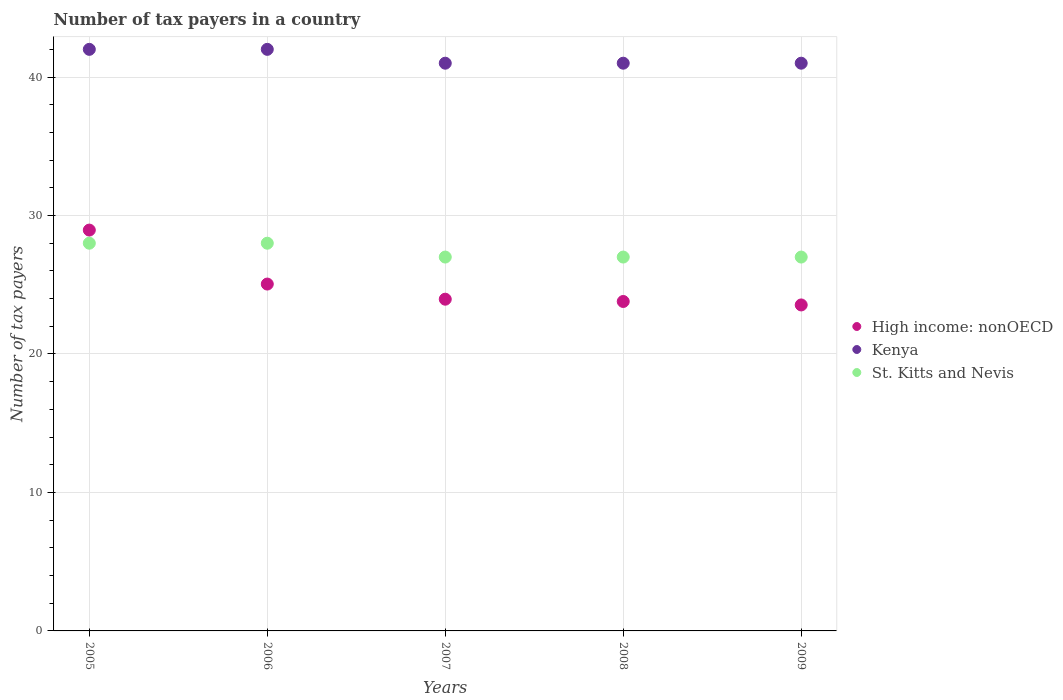How many different coloured dotlines are there?
Your answer should be compact. 3. What is the number of tax payers in in Kenya in 2008?
Make the answer very short. 41. Across all years, what is the maximum number of tax payers in in High income: nonOECD?
Your answer should be compact. 28.95. Across all years, what is the minimum number of tax payers in in Kenya?
Your answer should be very brief. 41. In which year was the number of tax payers in in Kenya maximum?
Your answer should be compact. 2005. In which year was the number of tax payers in in St. Kitts and Nevis minimum?
Offer a very short reply. 2007. What is the total number of tax payers in in High income: nonOECD in the graph?
Your answer should be compact. 125.29. What is the difference between the number of tax payers in in High income: nonOECD in 2007 and that in 2009?
Provide a succinct answer. 0.41. What is the difference between the number of tax payers in in St. Kitts and Nevis in 2006 and the number of tax payers in in Kenya in 2008?
Your answer should be compact. -13. What is the average number of tax payers in in High income: nonOECD per year?
Provide a succinct answer. 25.06. In the year 2005, what is the difference between the number of tax payers in in High income: nonOECD and number of tax payers in in St. Kitts and Nevis?
Offer a terse response. 0.95. What is the ratio of the number of tax payers in in High income: nonOECD in 2006 to that in 2007?
Provide a short and direct response. 1.05. Is the number of tax payers in in High income: nonOECD in 2008 less than that in 2009?
Give a very brief answer. No. Is the difference between the number of tax payers in in High income: nonOECD in 2007 and 2009 greater than the difference between the number of tax payers in in St. Kitts and Nevis in 2007 and 2009?
Your answer should be compact. Yes. What is the difference between the highest and the second highest number of tax payers in in St. Kitts and Nevis?
Provide a succinct answer. 0. What is the difference between the highest and the lowest number of tax payers in in Kenya?
Ensure brevity in your answer.  1. In how many years, is the number of tax payers in in Kenya greater than the average number of tax payers in in Kenya taken over all years?
Your answer should be very brief. 2. Is the sum of the number of tax payers in in Kenya in 2008 and 2009 greater than the maximum number of tax payers in in St. Kitts and Nevis across all years?
Offer a terse response. Yes. Is it the case that in every year, the sum of the number of tax payers in in St. Kitts and Nevis and number of tax payers in in High income: nonOECD  is greater than the number of tax payers in in Kenya?
Your answer should be very brief. Yes. Does the number of tax payers in in St. Kitts and Nevis monotonically increase over the years?
Your answer should be compact. No. Is the number of tax payers in in High income: nonOECD strictly less than the number of tax payers in in St. Kitts and Nevis over the years?
Your response must be concise. No. How many years are there in the graph?
Provide a succinct answer. 5. What is the difference between two consecutive major ticks on the Y-axis?
Give a very brief answer. 10. Are the values on the major ticks of Y-axis written in scientific E-notation?
Your answer should be compact. No. Does the graph contain any zero values?
Offer a very short reply. No. How many legend labels are there?
Offer a very short reply. 3. How are the legend labels stacked?
Offer a very short reply. Vertical. What is the title of the graph?
Your response must be concise. Number of tax payers in a country. What is the label or title of the Y-axis?
Provide a short and direct response. Number of tax payers. What is the Number of tax payers in High income: nonOECD in 2005?
Your answer should be very brief. 28.95. What is the Number of tax payers in St. Kitts and Nevis in 2005?
Your answer should be very brief. 28. What is the Number of tax payers in High income: nonOECD in 2006?
Your answer should be very brief. 25.05. What is the Number of tax payers of Kenya in 2006?
Ensure brevity in your answer.  42. What is the Number of tax payers in St. Kitts and Nevis in 2006?
Your answer should be very brief. 28. What is the Number of tax payers in High income: nonOECD in 2007?
Provide a short and direct response. 23.96. What is the Number of tax payers in Kenya in 2007?
Your answer should be compact. 41. What is the Number of tax payers of St. Kitts and Nevis in 2007?
Offer a very short reply. 27. What is the Number of tax payers in High income: nonOECD in 2008?
Offer a terse response. 23.79. What is the Number of tax payers of High income: nonOECD in 2009?
Your answer should be compact. 23.54. Across all years, what is the maximum Number of tax payers in High income: nonOECD?
Offer a very short reply. 28.95. Across all years, what is the minimum Number of tax payers in High income: nonOECD?
Provide a short and direct response. 23.54. Across all years, what is the minimum Number of tax payers of St. Kitts and Nevis?
Your answer should be compact. 27. What is the total Number of tax payers in High income: nonOECD in the graph?
Offer a very short reply. 125.29. What is the total Number of tax payers of Kenya in the graph?
Make the answer very short. 207. What is the total Number of tax payers of St. Kitts and Nevis in the graph?
Offer a very short reply. 137. What is the difference between the Number of tax payers of High income: nonOECD in 2005 and that in 2006?
Your response must be concise. 3.9. What is the difference between the Number of tax payers of St. Kitts and Nevis in 2005 and that in 2006?
Your answer should be very brief. 0. What is the difference between the Number of tax payers of High income: nonOECD in 2005 and that in 2007?
Provide a succinct answer. 4.99. What is the difference between the Number of tax payers of Kenya in 2005 and that in 2007?
Offer a terse response. 1. What is the difference between the Number of tax payers of High income: nonOECD in 2005 and that in 2008?
Give a very brief answer. 5.16. What is the difference between the Number of tax payers of Kenya in 2005 and that in 2008?
Make the answer very short. 1. What is the difference between the Number of tax payers in St. Kitts and Nevis in 2005 and that in 2008?
Ensure brevity in your answer.  1. What is the difference between the Number of tax payers in High income: nonOECD in 2005 and that in 2009?
Your response must be concise. 5.41. What is the difference between the Number of tax payers in Kenya in 2005 and that in 2009?
Provide a short and direct response. 1. What is the difference between the Number of tax payers of St. Kitts and Nevis in 2005 and that in 2009?
Provide a succinct answer. 1. What is the difference between the Number of tax payers of High income: nonOECD in 2006 and that in 2007?
Ensure brevity in your answer.  1.09. What is the difference between the Number of tax payers of High income: nonOECD in 2006 and that in 2008?
Offer a very short reply. 1.26. What is the difference between the Number of tax payers of Kenya in 2006 and that in 2008?
Your response must be concise. 1. What is the difference between the Number of tax payers of St. Kitts and Nevis in 2006 and that in 2008?
Your answer should be compact. 1. What is the difference between the Number of tax payers in High income: nonOECD in 2006 and that in 2009?
Ensure brevity in your answer.  1.51. What is the difference between the Number of tax payers of Kenya in 2006 and that in 2009?
Your answer should be compact. 1. What is the difference between the Number of tax payers in High income: nonOECD in 2007 and that in 2008?
Provide a short and direct response. 0.16. What is the difference between the Number of tax payers of St. Kitts and Nevis in 2007 and that in 2008?
Your answer should be very brief. 0. What is the difference between the Number of tax payers of High income: nonOECD in 2007 and that in 2009?
Give a very brief answer. 0.41. What is the difference between the Number of tax payers of High income: nonOECD in 2008 and that in 2009?
Offer a very short reply. 0.25. What is the difference between the Number of tax payers of St. Kitts and Nevis in 2008 and that in 2009?
Your response must be concise. 0. What is the difference between the Number of tax payers in High income: nonOECD in 2005 and the Number of tax payers in Kenya in 2006?
Keep it short and to the point. -13.05. What is the difference between the Number of tax payers in Kenya in 2005 and the Number of tax payers in St. Kitts and Nevis in 2006?
Keep it short and to the point. 14. What is the difference between the Number of tax payers of High income: nonOECD in 2005 and the Number of tax payers of Kenya in 2007?
Make the answer very short. -12.05. What is the difference between the Number of tax payers of High income: nonOECD in 2005 and the Number of tax payers of St. Kitts and Nevis in 2007?
Keep it short and to the point. 1.95. What is the difference between the Number of tax payers of High income: nonOECD in 2005 and the Number of tax payers of Kenya in 2008?
Ensure brevity in your answer.  -12.05. What is the difference between the Number of tax payers in High income: nonOECD in 2005 and the Number of tax payers in St. Kitts and Nevis in 2008?
Keep it short and to the point. 1.95. What is the difference between the Number of tax payers in High income: nonOECD in 2005 and the Number of tax payers in Kenya in 2009?
Make the answer very short. -12.05. What is the difference between the Number of tax payers of High income: nonOECD in 2005 and the Number of tax payers of St. Kitts and Nevis in 2009?
Make the answer very short. 1.95. What is the difference between the Number of tax payers in Kenya in 2005 and the Number of tax payers in St. Kitts and Nevis in 2009?
Your answer should be compact. 15. What is the difference between the Number of tax payers of High income: nonOECD in 2006 and the Number of tax payers of Kenya in 2007?
Your answer should be compact. -15.95. What is the difference between the Number of tax payers in High income: nonOECD in 2006 and the Number of tax payers in St. Kitts and Nevis in 2007?
Provide a succinct answer. -1.95. What is the difference between the Number of tax payers of Kenya in 2006 and the Number of tax payers of St. Kitts and Nevis in 2007?
Give a very brief answer. 15. What is the difference between the Number of tax payers of High income: nonOECD in 2006 and the Number of tax payers of Kenya in 2008?
Offer a terse response. -15.95. What is the difference between the Number of tax payers of High income: nonOECD in 2006 and the Number of tax payers of St. Kitts and Nevis in 2008?
Ensure brevity in your answer.  -1.95. What is the difference between the Number of tax payers of High income: nonOECD in 2006 and the Number of tax payers of Kenya in 2009?
Provide a succinct answer. -15.95. What is the difference between the Number of tax payers in High income: nonOECD in 2006 and the Number of tax payers in St. Kitts and Nevis in 2009?
Give a very brief answer. -1.95. What is the difference between the Number of tax payers of Kenya in 2006 and the Number of tax payers of St. Kitts and Nevis in 2009?
Your response must be concise. 15. What is the difference between the Number of tax payers of High income: nonOECD in 2007 and the Number of tax payers of Kenya in 2008?
Your answer should be compact. -17.04. What is the difference between the Number of tax payers of High income: nonOECD in 2007 and the Number of tax payers of St. Kitts and Nevis in 2008?
Make the answer very short. -3.04. What is the difference between the Number of tax payers of High income: nonOECD in 2007 and the Number of tax payers of Kenya in 2009?
Your answer should be very brief. -17.04. What is the difference between the Number of tax payers of High income: nonOECD in 2007 and the Number of tax payers of St. Kitts and Nevis in 2009?
Provide a short and direct response. -3.04. What is the difference between the Number of tax payers in Kenya in 2007 and the Number of tax payers in St. Kitts and Nevis in 2009?
Offer a very short reply. 14. What is the difference between the Number of tax payers of High income: nonOECD in 2008 and the Number of tax payers of Kenya in 2009?
Your answer should be very brief. -17.21. What is the difference between the Number of tax payers of High income: nonOECD in 2008 and the Number of tax payers of St. Kitts and Nevis in 2009?
Provide a short and direct response. -3.21. What is the difference between the Number of tax payers in Kenya in 2008 and the Number of tax payers in St. Kitts and Nevis in 2009?
Offer a very short reply. 14. What is the average Number of tax payers in High income: nonOECD per year?
Give a very brief answer. 25.06. What is the average Number of tax payers of Kenya per year?
Your answer should be compact. 41.4. What is the average Number of tax payers in St. Kitts and Nevis per year?
Your answer should be compact. 27.4. In the year 2005, what is the difference between the Number of tax payers of High income: nonOECD and Number of tax payers of Kenya?
Your answer should be very brief. -13.05. In the year 2006, what is the difference between the Number of tax payers of High income: nonOECD and Number of tax payers of Kenya?
Provide a short and direct response. -16.95. In the year 2006, what is the difference between the Number of tax payers of High income: nonOECD and Number of tax payers of St. Kitts and Nevis?
Provide a succinct answer. -2.95. In the year 2006, what is the difference between the Number of tax payers in Kenya and Number of tax payers in St. Kitts and Nevis?
Keep it short and to the point. 14. In the year 2007, what is the difference between the Number of tax payers of High income: nonOECD and Number of tax payers of Kenya?
Your answer should be compact. -17.04. In the year 2007, what is the difference between the Number of tax payers in High income: nonOECD and Number of tax payers in St. Kitts and Nevis?
Give a very brief answer. -3.04. In the year 2007, what is the difference between the Number of tax payers in Kenya and Number of tax payers in St. Kitts and Nevis?
Keep it short and to the point. 14. In the year 2008, what is the difference between the Number of tax payers in High income: nonOECD and Number of tax payers in Kenya?
Your answer should be very brief. -17.21. In the year 2008, what is the difference between the Number of tax payers of High income: nonOECD and Number of tax payers of St. Kitts and Nevis?
Provide a succinct answer. -3.21. In the year 2008, what is the difference between the Number of tax payers in Kenya and Number of tax payers in St. Kitts and Nevis?
Offer a very short reply. 14. In the year 2009, what is the difference between the Number of tax payers in High income: nonOECD and Number of tax payers in Kenya?
Give a very brief answer. -17.46. In the year 2009, what is the difference between the Number of tax payers in High income: nonOECD and Number of tax payers in St. Kitts and Nevis?
Make the answer very short. -3.46. What is the ratio of the Number of tax payers in High income: nonOECD in 2005 to that in 2006?
Keep it short and to the point. 1.16. What is the ratio of the Number of tax payers in Kenya in 2005 to that in 2006?
Provide a succinct answer. 1. What is the ratio of the Number of tax payers in High income: nonOECD in 2005 to that in 2007?
Keep it short and to the point. 1.21. What is the ratio of the Number of tax payers of Kenya in 2005 to that in 2007?
Provide a succinct answer. 1.02. What is the ratio of the Number of tax payers of St. Kitts and Nevis in 2005 to that in 2007?
Ensure brevity in your answer.  1.04. What is the ratio of the Number of tax payers in High income: nonOECD in 2005 to that in 2008?
Offer a very short reply. 1.22. What is the ratio of the Number of tax payers in Kenya in 2005 to that in 2008?
Offer a very short reply. 1.02. What is the ratio of the Number of tax payers in High income: nonOECD in 2005 to that in 2009?
Make the answer very short. 1.23. What is the ratio of the Number of tax payers of Kenya in 2005 to that in 2009?
Give a very brief answer. 1.02. What is the ratio of the Number of tax payers of High income: nonOECD in 2006 to that in 2007?
Your answer should be compact. 1.05. What is the ratio of the Number of tax payers in Kenya in 2006 to that in 2007?
Offer a very short reply. 1.02. What is the ratio of the Number of tax payers of St. Kitts and Nevis in 2006 to that in 2007?
Provide a succinct answer. 1.04. What is the ratio of the Number of tax payers of High income: nonOECD in 2006 to that in 2008?
Your response must be concise. 1.05. What is the ratio of the Number of tax payers of Kenya in 2006 to that in 2008?
Give a very brief answer. 1.02. What is the ratio of the Number of tax payers in High income: nonOECD in 2006 to that in 2009?
Your answer should be compact. 1.06. What is the ratio of the Number of tax payers of Kenya in 2006 to that in 2009?
Your answer should be compact. 1.02. What is the ratio of the Number of tax payers in St. Kitts and Nevis in 2006 to that in 2009?
Provide a succinct answer. 1.04. What is the ratio of the Number of tax payers in High income: nonOECD in 2007 to that in 2009?
Your response must be concise. 1.02. What is the ratio of the Number of tax payers of Kenya in 2007 to that in 2009?
Your answer should be compact. 1. What is the ratio of the Number of tax payers of High income: nonOECD in 2008 to that in 2009?
Your answer should be very brief. 1.01. What is the difference between the highest and the second highest Number of tax payers of High income: nonOECD?
Keep it short and to the point. 3.9. What is the difference between the highest and the second highest Number of tax payers of Kenya?
Offer a terse response. 0. What is the difference between the highest and the lowest Number of tax payers in High income: nonOECD?
Offer a very short reply. 5.41. 